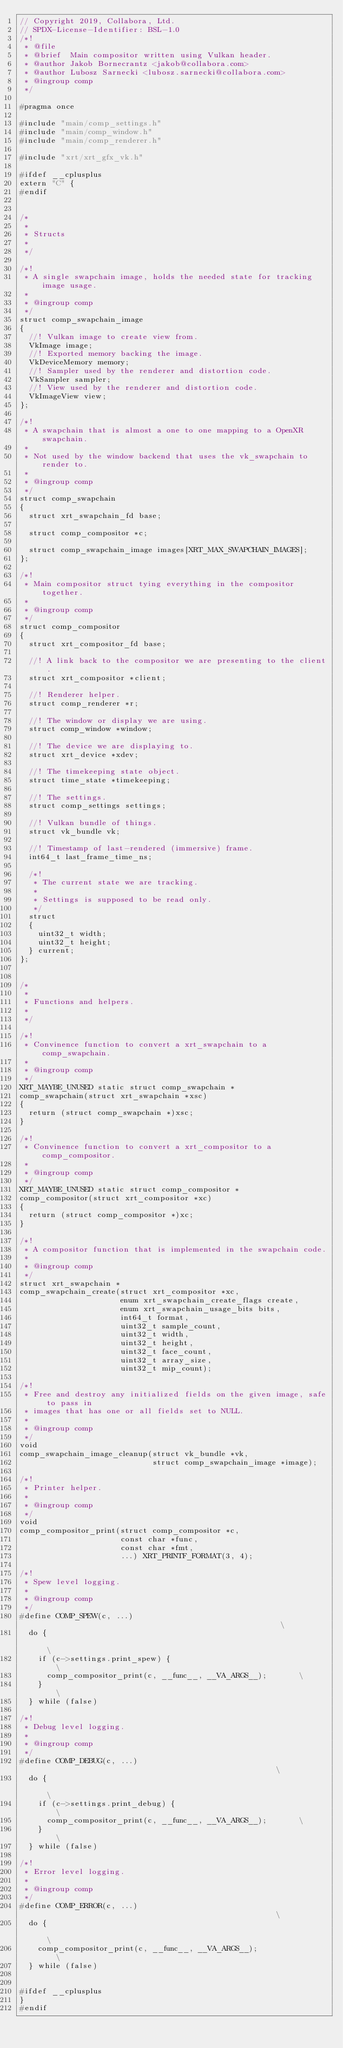Convert code to text. <code><loc_0><loc_0><loc_500><loc_500><_C_>// Copyright 2019, Collabora, Ltd.
// SPDX-License-Identifier: BSL-1.0
/*!
 * @file
 * @brief  Main compositor written using Vulkan header.
 * @author Jakob Bornecrantz <jakob@collabora.com>
 * @author Lubosz Sarnecki <lubosz.sarnecki@collabora.com>
 * @ingroup comp
 */

#pragma once

#include "main/comp_settings.h"
#include "main/comp_window.h"
#include "main/comp_renderer.h"

#include "xrt/xrt_gfx_vk.h"

#ifdef __cplusplus
extern "C" {
#endif


/*
 *
 * Structs
 *
 */

/*!
 * A single swapchain image, holds the needed state for tracking image usage.
 *
 * @ingroup comp
 */
struct comp_swapchain_image
{
	//! Vulkan image to create view from.
	VkImage image;
	//! Exported memory backing the image.
	VkDeviceMemory memory;
	//! Sampler used by the renderer and distortion code.
	VkSampler sampler;
	//! View used by the renderer and distortion code.
	VkImageView view;
};

/*!
 * A swapchain that is almost a one to one mapping to a OpenXR swapchain.
 *
 * Not used by the window backend that uses the vk_swapchain to render to.
 *
 * @ingroup comp
 */
struct comp_swapchain
{
	struct xrt_swapchain_fd base;

	struct comp_compositor *c;

	struct comp_swapchain_image images[XRT_MAX_SWAPCHAIN_IMAGES];
};

/*!
 * Main compositor struct tying everything in the compositor together.
 *
 * @ingroup comp
 */
struct comp_compositor
{
	struct xrt_compositor_fd base;

	//! A link back to the compositor we are presenting to the client.
	struct xrt_compositor *client;

	//! Renderer helper.
	struct comp_renderer *r;

	//! The window or display we are using.
	struct comp_window *window;

	//! The device we are displaying to.
	struct xrt_device *xdev;

	//! The timekeeping state object.
	struct time_state *timekeeping;

	//! The settings.
	struct comp_settings settings;

	//! Vulkan bundle of things.
	struct vk_bundle vk;

	//! Timestamp of last-rendered (immersive) frame.
	int64_t last_frame_time_ns;

	/*!
	 * The current state we are tracking.
	 *
	 * Settings is supposed to be read only.
	 */
	struct
	{
		uint32_t width;
		uint32_t height;
	} current;
};


/*
 *
 * Functions and helpers.
 *
 */

/*!
 * Convinence function to convert a xrt_swapchain to a comp_swapchain.
 *
 * @ingroup comp
 */
XRT_MAYBE_UNUSED static struct comp_swapchain *
comp_swapchain(struct xrt_swapchain *xsc)
{
	return (struct comp_swapchain *)xsc;
}

/*!
 * Convinence function to convert a xrt_compositor to a comp_compositor.
 *
 * @ingroup comp
 */
XRT_MAYBE_UNUSED static struct comp_compositor *
comp_compositor(struct xrt_compositor *xc)
{
	return (struct comp_compositor *)xc;
}

/*!
 * A compositor function that is implemented in the swapchain code.
 *
 * @ingroup comp
 */
struct xrt_swapchain *
comp_swapchain_create(struct xrt_compositor *xc,
                      enum xrt_swapchain_create_flags create,
                      enum xrt_swapchain_usage_bits bits,
                      int64_t format,
                      uint32_t sample_count,
                      uint32_t width,
                      uint32_t height,
                      uint32_t face_count,
                      uint32_t array_size,
                      uint32_t mip_count);

/*!
 * Free and destroy any initialized fields on the given image, safe to pass in
 * images that has one or all fields set to NULL.
 *
 * @ingroup comp
 */
void
comp_swapchain_image_cleanup(struct vk_bundle *vk,
                             struct comp_swapchain_image *image);

/*!
 * Printer helper.
 *
 * @ingroup comp
 */
void
comp_compositor_print(struct comp_compositor *c,
                      const char *func,
                      const char *fmt,
                      ...) XRT_PRINTF_FORMAT(3, 4);

/*!
 * Spew level logging.
 *
 * @ingroup comp
 */
#define COMP_SPEW(c, ...)                                                      \
	do {                                                                   \
		if (c->settings.print_spew) {                                  \
			comp_compositor_print(c, __func__, __VA_ARGS__);       \
		}                                                              \
	} while (false)

/*!
 * Debug level logging.
 *
 * @ingroup comp
 */
#define COMP_DEBUG(c, ...)                                                     \
	do {                                                                   \
		if (c->settings.print_debug) {                                 \
			comp_compositor_print(c, __func__, __VA_ARGS__);       \
		}                                                              \
	} while (false)

/*!
 * Error level logging.
 *
 * @ingroup comp
 */
#define COMP_ERROR(c, ...)                                                     \
	do {                                                                   \
		comp_compositor_print(c, __func__, __VA_ARGS__);               \
	} while (false)


#ifdef __cplusplus
}
#endif
</code> 